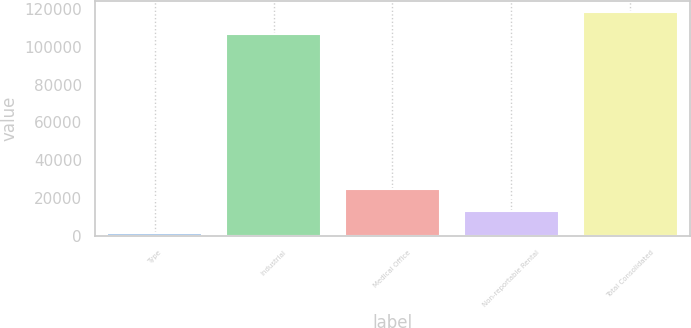<chart> <loc_0><loc_0><loc_500><loc_500><bar_chart><fcel>Type<fcel>Industrial<fcel>Medical Office<fcel>Non-reportable Rental<fcel>Total Consolidated<nl><fcel>2015<fcel>106828<fcel>24729.6<fcel>13372.3<fcel>118185<nl></chart> 